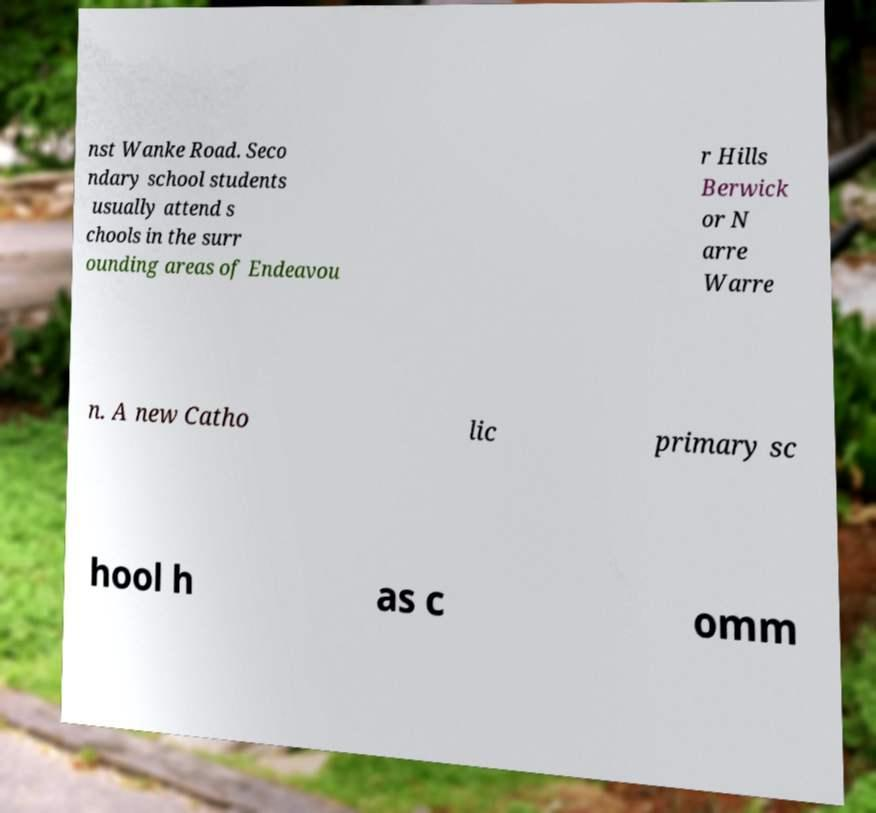Could you assist in decoding the text presented in this image and type it out clearly? nst Wanke Road. Seco ndary school students usually attend s chools in the surr ounding areas of Endeavou r Hills Berwick or N arre Warre n. A new Catho lic primary sc hool h as c omm 